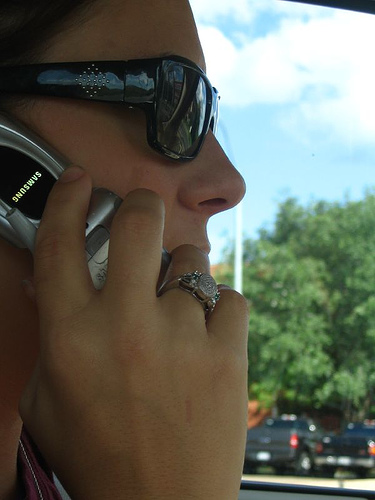<image>Is this woman married? I don't know if this woman is married. It can be both yes and no. Is this woman married? I don't know if this woman is married. It can be both yes or no. 